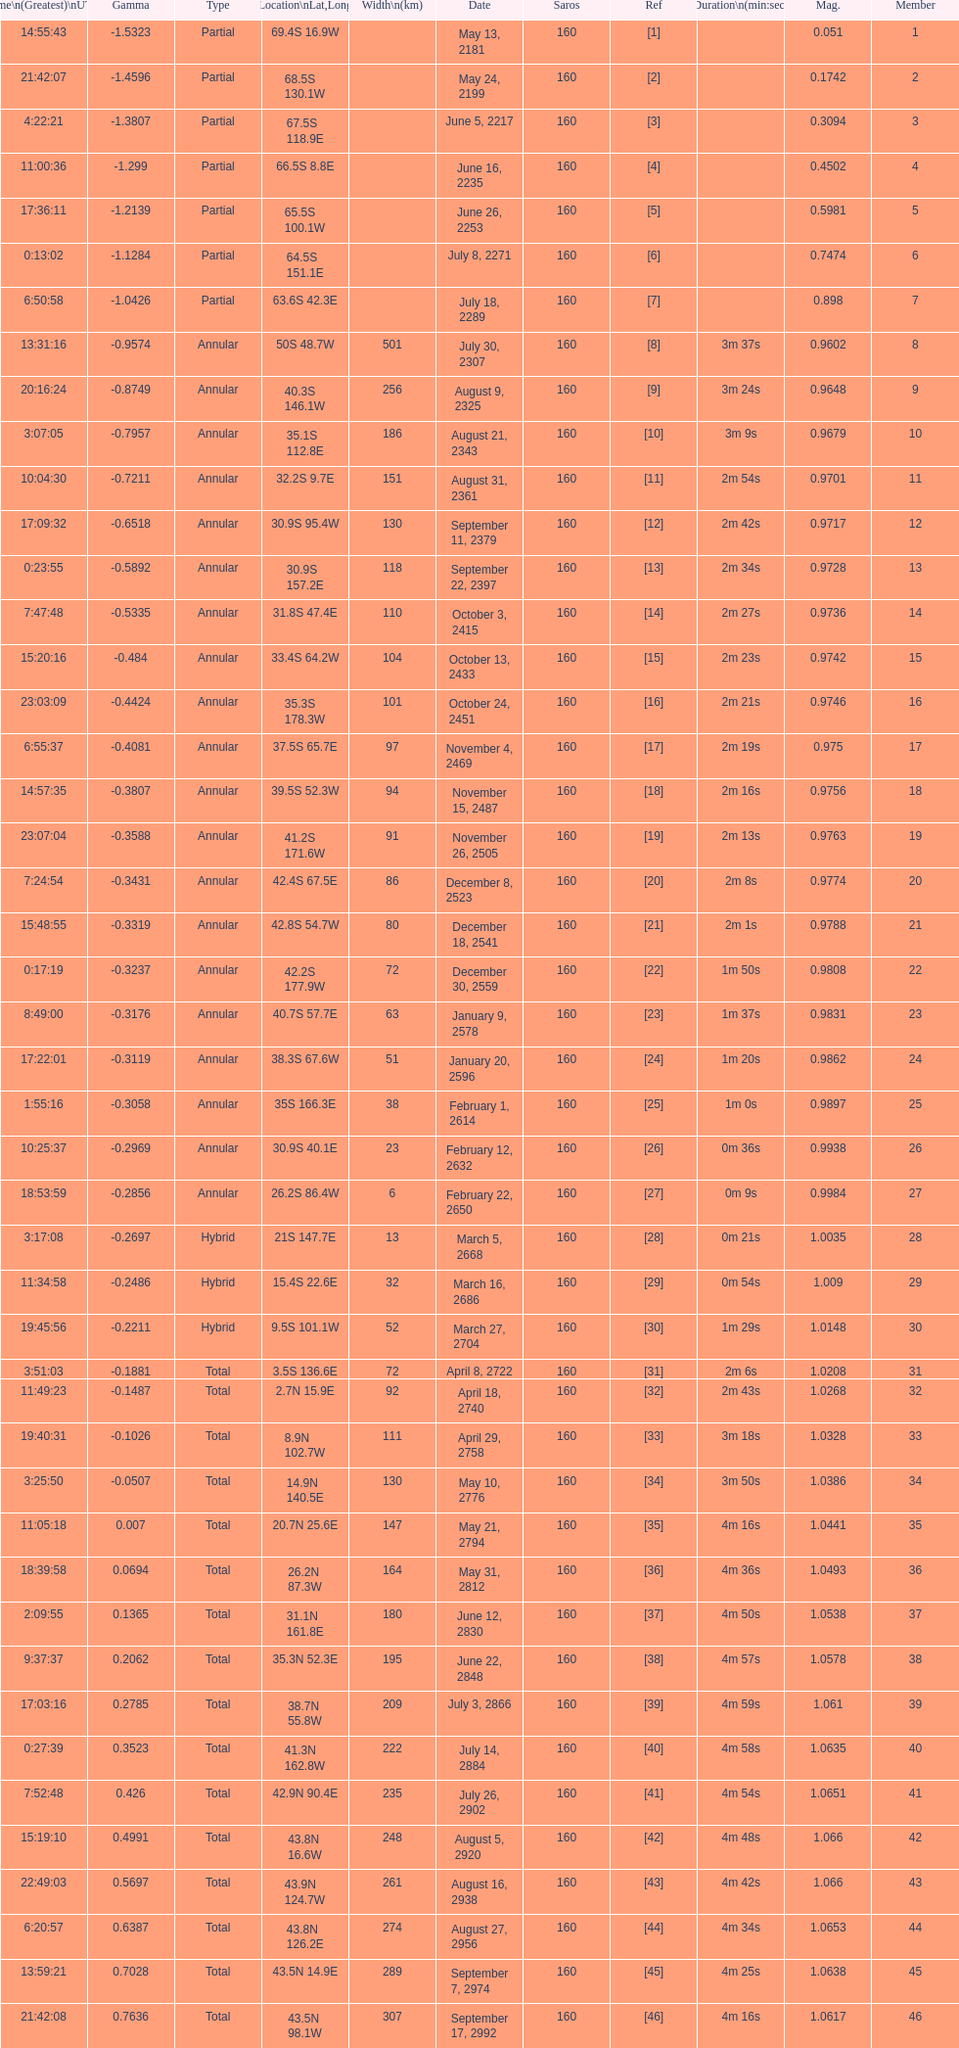How many solar saros events lasted longer than 4 minutes? 12. 